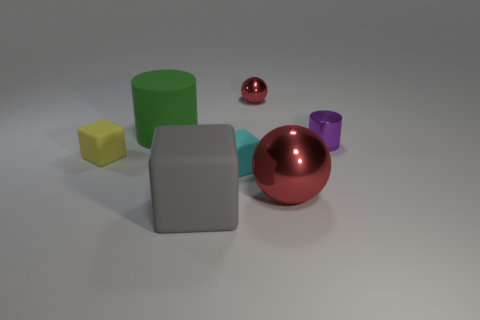There is a yellow object that is the same shape as the cyan thing; what is it made of?
Ensure brevity in your answer.  Rubber. Is the large red object made of the same material as the large cylinder?
Ensure brevity in your answer.  No. Do the yellow matte block and the cyan cube have the same size?
Offer a very short reply. Yes. What number of tiny things have the same color as the big rubber cube?
Ensure brevity in your answer.  0. How many tiny objects are either red shiny things or cyan rubber objects?
Ensure brevity in your answer.  2. Is there a red shiny thing of the same shape as the small yellow thing?
Keep it short and to the point. No. Do the small purple object and the large green matte thing have the same shape?
Your response must be concise. Yes. What is the color of the cylinder that is on the left side of the red object right of the small metallic ball?
Make the answer very short. Green. The ball that is the same size as the purple metal thing is what color?
Ensure brevity in your answer.  Red. What number of metallic objects are either yellow things or small blue things?
Offer a very short reply. 0. 